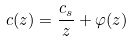<formula> <loc_0><loc_0><loc_500><loc_500>c ( z ) = \frac { c _ { s } } { z } + \varphi ( z )</formula> 